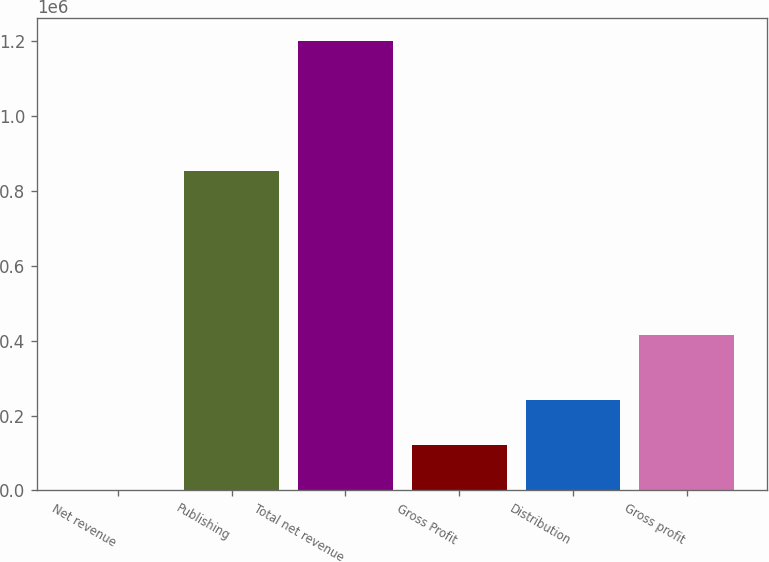Convert chart. <chart><loc_0><loc_0><loc_500><loc_500><bar_chart><fcel>Net revenue<fcel>Publishing<fcel>Total net revenue<fcel>Gross Profit<fcel>Distribution<fcel>Gross profit<nl><fcel>2005<fcel>851862<fcel>1.20122e+06<fcel>121926<fcel>241848<fcel>414842<nl></chart> 